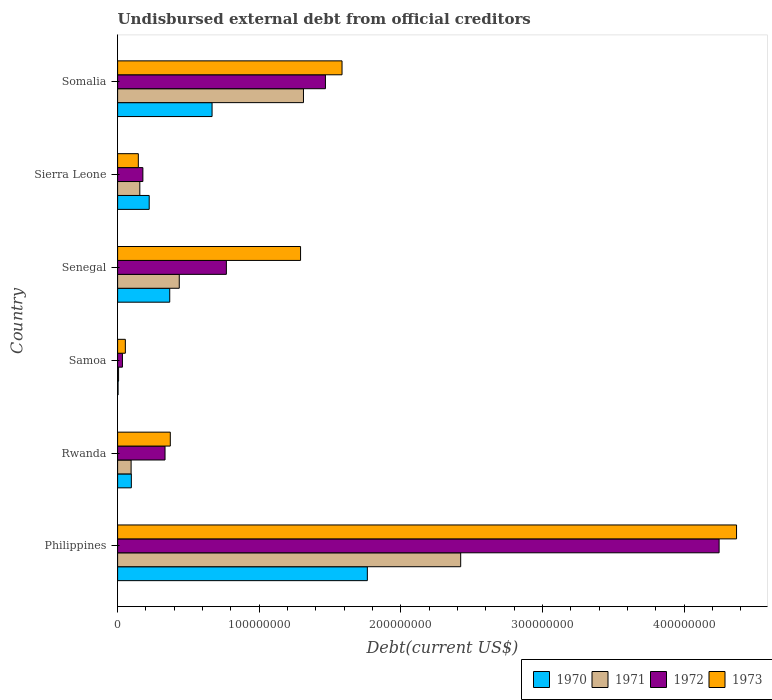Are the number of bars on each tick of the Y-axis equal?
Keep it short and to the point. Yes. What is the label of the 3rd group of bars from the top?
Offer a very short reply. Senegal. In how many cases, is the number of bars for a given country not equal to the number of legend labels?
Your answer should be compact. 0. What is the total debt in 1970 in Sierra Leone?
Offer a terse response. 2.23e+07. Across all countries, what is the maximum total debt in 1973?
Make the answer very short. 4.37e+08. Across all countries, what is the minimum total debt in 1971?
Make the answer very short. 6.88e+05. In which country was the total debt in 1971 minimum?
Offer a terse response. Samoa. What is the total total debt in 1972 in the graph?
Your answer should be compact. 7.03e+08. What is the difference between the total debt in 1971 in Sierra Leone and that in Somalia?
Your answer should be very brief. -1.16e+08. What is the difference between the total debt in 1970 in Rwanda and the total debt in 1971 in Senegal?
Make the answer very short. -3.38e+07. What is the average total debt in 1972 per country?
Your response must be concise. 1.17e+08. What is the difference between the total debt in 1970 and total debt in 1971 in Sierra Leone?
Provide a short and direct response. 6.63e+06. In how many countries, is the total debt in 1972 greater than 260000000 US$?
Your answer should be compact. 1. What is the ratio of the total debt in 1972 in Philippines to that in Sierra Leone?
Give a very brief answer. 23.8. What is the difference between the highest and the second highest total debt in 1970?
Give a very brief answer. 1.10e+08. What is the difference between the highest and the lowest total debt in 1973?
Keep it short and to the point. 4.32e+08. Is the sum of the total debt in 1970 in Sierra Leone and Somalia greater than the maximum total debt in 1973 across all countries?
Provide a succinct answer. No. Is it the case that in every country, the sum of the total debt in 1973 and total debt in 1970 is greater than the total debt in 1971?
Make the answer very short. Yes. What is the difference between two consecutive major ticks on the X-axis?
Your answer should be compact. 1.00e+08. Does the graph contain grids?
Your answer should be very brief. No. How are the legend labels stacked?
Offer a very short reply. Horizontal. What is the title of the graph?
Your response must be concise. Undisbursed external debt from official creditors. Does "1982" appear as one of the legend labels in the graph?
Give a very brief answer. No. What is the label or title of the X-axis?
Your response must be concise. Debt(current US$). What is the Debt(current US$) in 1970 in Philippines?
Provide a succinct answer. 1.76e+08. What is the Debt(current US$) of 1971 in Philippines?
Provide a succinct answer. 2.42e+08. What is the Debt(current US$) in 1972 in Philippines?
Your answer should be compact. 4.25e+08. What is the Debt(current US$) in 1973 in Philippines?
Keep it short and to the point. 4.37e+08. What is the Debt(current US$) in 1970 in Rwanda?
Ensure brevity in your answer.  9.70e+06. What is the Debt(current US$) in 1971 in Rwanda?
Ensure brevity in your answer.  9.53e+06. What is the Debt(current US$) in 1972 in Rwanda?
Make the answer very short. 3.35e+07. What is the Debt(current US$) of 1973 in Rwanda?
Your answer should be compact. 3.72e+07. What is the Debt(current US$) in 1970 in Samoa?
Offer a terse response. 3.36e+05. What is the Debt(current US$) of 1971 in Samoa?
Ensure brevity in your answer.  6.88e+05. What is the Debt(current US$) in 1972 in Samoa?
Offer a very short reply. 3.40e+06. What is the Debt(current US$) of 1973 in Samoa?
Make the answer very short. 5.46e+06. What is the Debt(current US$) of 1970 in Senegal?
Provide a succinct answer. 3.68e+07. What is the Debt(current US$) of 1971 in Senegal?
Your answer should be very brief. 4.35e+07. What is the Debt(current US$) of 1972 in Senegal?
Offer a very short reply. 7.68e+07. What is the Debt(current US$) in 1973 in Senegal?
Ensure brevity in your answer.  1.29e+08. What is the Debt(current US$) in 1970 in Sierra Leone?
Your answer should be very brief. 2.23e+07. What is the Debt(current US$) of 1971 in Sierra Leone?
Provide a succinct answer. 1.57e+07. What is the Debt(current US$) in 1972 in Sierra Leone?
Ensure brevity in your answer.  1.78e+07. What is the Debt(current US$) in 1973 in Sierra Leone?
Provide a short and direct response. 1.46e+07. What is the Debt(current US$) of 1970 in Somalia?
Provide a short and direct response. 6.67e+07. What is the Debt(current US$) of 1971 in Somalia?
Make the answer very short. 1.31e+08. What is the Debt(current US$) of 1972 in Somalia?
Make the answer very short. 1.47e+08. What is the Debt(current US$) of 1973 in Somalia?
Your response must be concise. 1.58e+08. Across all countries, what is the maximum Debt(current US$) of 1970?
Give a very brief answer. 1.76e+08. Across all countries, what is the maximum Debt(current US$) of 1971?
Your answer should be compact. 2.42e+08. Across all countries, what is the maximum Debt(current US$) of 1972?
Your answer should be compact. 4.25e+08. Across all countries, what is the maximum Debt(current US$) of 1973?
Ensure brevity in your answer.  4.37e+08. Across all countries, what is the minimum Debt(current US$) in 1970?
Your answer should be very brief. 3.36e+05. Across all countries, what is the minimum Debt(current US$) in 1971?
Keep it short and to the point. 6.88e+05. Across all countries, what is the minimum Debt(current US$) in 1972?
Offer a terse response. 3.40e+06. Across all countries, what is the minimum Debt(current US$) in 1973?
Give a very brief answer. 5.46e+06. What is the total Debt(current US$) in 1970 in the graph?
Keep it short and to the point. 3.12e+08. What is the total Debt(current US$) in 1971 in the graph?
Provide a succinct answer. 4.43e+08. What is the total Debt(current US$) of 1972 in the graph?
Your answer should be compact. 7.03e+08. What is the total Debt(current US$) of 1973 in the graph?
Your response must be concise. 7.82e+08. What is the difference between the Debt(current US$) of 1970 in Philippines and that in Rwanda?
Provide a succinct answer. 1.67e+08. What is the difference between the Debt(current US$) of 1971 in Philippines and that in Rwanda?
Provide a succinct answer. 2.33e+08. What is the difference between the Debt(current US$) in 1972 in Philippines and that in Rwanda?
Make the answer very short. 3.91e+08. What is the difference between the Debt(current US$) of 1973 in Philippines and that in Rwanda?
Provide a succinct answer. 4.00e+08. What is the difference between the Debt(current US$) in 1970 in Philippines and that in Samoa?
Keep it short and to the point. 1.76e+08. What is the difference between the Debt(current US$) of 1971 in Philippines and that in Samoa?
Make the answer very short. 2.42e+08. What is the difference between the Debt(current US$) of 1972 in Philippines and that in Samoa?
Your response must be concise. 4.21e+08. What is the difference between the Debt(current US$) of 1973 in Philippines and that in Samoa?
Offer a terse response. 4.32e+08. What is the difference between the Debt(current US$) of 1970 in Philippines and that in Senegal?
Make the answer very short. 1.40e+08. What is the difference between the Debt(current US$) in 1971 in Philippines and that in Senegal?
Make the answer very short. 1.99e+08. What is the difference between the Debt(current US$) of 1972 in Philippines and that in Senegal?
Offer a terse response. 3.48e+08. What is the difference between the Debt(current US$) in 1973 in Philippines and that in Senegal?
Provide a short and direct response. 3.08e+08. What is the difference between the Debt(current US$) of 1970 in Philippines and that in Sierra Leone?
Ensure brevity in your answer.  1.54e+08. What is the difference between the Debt(current US$) of 1971 in Philippines and that in Sierra Leone?
Keep it short and to the point. 2.27e+08. What is the difference between the Debt(current US$) in 1972 in Philippines and that in Sierra Leone?
Keep it short and to the point. 4.07e+08. What is the difference between the Debt(current US$) of 1973 in Philippines and that in Sierra Leone?
Your answer should be compact. 4.22e+08. What is the difference between the Debt(current US$) of 1970 in Philippines and that in Somalia?
Give a very brief answer. 1.10e+08. What is the difference between the Debt(current US$) in 1971 in Philippines and that in Somalia?
Ensure brevity in your answer.  1.11e+08. What is the difference between the Debt(current US$) in 1972 in Philippines and that in Somalia?
Offer a very short reply. 2.78e+08. What is the difference between the Debt(current US$) in 1973 in Philippines and that in Somalia?
Your answer should be very brief. 2.79e+08. What is the difference between the Debt(current US$) in 1970 in Rwanda and that in Samoa?
Your answer should be compact. 9.36e+06. What is the difference between the Debt(current US$) of 1971 in Rwanda and that in Samoa?
Your answer should be very brief. 8.84e+06. What is the difference between the Debt(current US$) in 1972 in Rwanda and that in Samoa?
Provide a succinct answer. 3.01e+07. What is the difference between the Debt(current US$) of 1973 in Rwanda and that in Samoa?
Your answer should be compact. 3.17e+07. What is the difference between the Debt(current US$) in 1970 in Rwanda and that in Senegal?
Provide a short and direct response. -2.71e+07. What is the difference between the Debt(current US$) of 1971 in Rwanda and that in Senegal?
Make the answer very short. -3.40e+07. What is the difference between the Debt(current US$) of 1972 in Rwanda and that in Senegal?
Ensure brevity in your answer.  -4.33e+07. What is the difference between the Debt(current US$) in 1973 in Rwanda and that in Senegal?
Your answer should be very brief. -9.20e+07. What is the difference between the Debt(current US$) in 1970 in Rwanda and that in Sierra Leone?
Your answer should be compact. -1.26e+07. What is the difference between the Debt(current US$) in 1971 in Rwanda and that in Sierra Leone?
Your answer should be compact. -6.14e+06. What is the difference between the Debt(current US$) in 1972 in Rwanda and that in Sierra Leone?
Keep it short and to the point. 1.56e+07. What is the difference between the Debt(current US$) of 1973 in Rwanda and that in Sierra Leone?
Make the answer very short. 2.26e+07. What is the difference between the Debt(current US$) in 1970 in Rwanda and that in Somalia?
Your response must be concise. -5.70e+07. What is the difference between the Debt(current US$) in 1971 in Rwanda and that in Somalia?
Ensure brevity in your answer.  -1.22e+08. What is the difference between the Debt(current US$) of 1972 in Rwanda and that in Somalia?
Provide a succinct answer. -1.13e+08. What is the difference between the Debt(current US$) in 1973 in Rwanda and that in Somalia?
Your answer should be very brief. -1.21e+08. What is the difference between the Debt(current US$) in 1970 in Samoa and that in Senegal?
Your answer should be very brief. -3.65e+07. What is the difference between the Debt(current US$) of 1971 in Samoa and that in Senegal?
Your answer should be very brief. -4.29e+07. What is the difference between the Debt(current US$) of 1972 in Samoa and that in Senegal?
Give a very brief answer. -7.34e+07. What is the difference between the Debt(current US$) of 1973 in Samoa and that in Senegal?
Keep it short and to the point. -1.24e+08. What is the difference between the Debt(current US$) in 1970 in Samoa and that in Sierra Leone?
Offer a terse response. -2.20e+07. What is the difference between the Debt(current US$) of 1971 in Samoa and that in Sierra Leone?
Provide a succinct answer. -1.50e+07. What is the difference between the Debt(current US$) in 1972 in Samoa and that in Sierra Leone?
Give a very brief answer. -1.44e+07. What is the difference between the Debt(current US$) of 1973 in Samoa and that in Sierra Leone?
Your answer should be compact. -9.17e+06. What is the difference between the Debt(current US$) of 1970 in Samoa and that in Somalia?
Your response must be concise. -6.64e+07. What is the difference between the Debt(current US$) in 1971 in Samoa and that in Somalia?
Make the answer very short. -1.31e+08. What is the difference between the Debt(current US$) of 1972 in Samoa and that in Somalia?
Offer a terse response. -1.43e+08. What is the difference between the Debt(current US$) of 1973 in Samoa and that in Somalia?
Provide a succinct answer. -1.53e+08. What is the difference between the Debt(current US$) in 1970 in Senegal and that in Sierra Leone?
Ensure brevity in your answer.  1.45e+07. What is the difference between the Debt(current US$) in 1971 in Senegal and that in Sierra Leone?
Provide a short and direct response. 2.79e+07. What is the difference between the Debt(current US$) in 1972 in Senegal and that in Sierra Leone?
Offer a very short reply. 5.90e+07. What is the difference between the Debt(current US$) in 1973 in Senegal and that in Sierra Leone?
Provide a short and direct response. 1.15e+08. What is the difference between the Debt(current US$) of 1970 in Senegal and that in Somalia?
Provide a succinct answer. -2.99e+07. What is the difference between the Debt(current US$) of 1971 in Senegal and that in Somalia?
Make the answer very short. -8.77e+07. What is the difference between the Debt(current US$) of 1972 in Senegal and that in Somalia?
Your answer should be compact. -7.00e+07. What is the difference between the Debt(current US$) in 1973 in Senegal and that in Somalia?
Provide a short and direct response. -2.93e+07. What is the difference between the Debt(current US$) in 1970 in Sierra Leone and that in Somalia?
Ensure brevity in your answer.  -4.44e+07. What is the difference between the Debt(current US$) of 1971 in Sierra Leone and that in Somalia?
Provide a short and direct response. -1.16e+08. What is the difference between the Debt(current US$) in 1972 in Sierra Leone and that in Somalia?
Provide a succinct answer. -1.29e+08. What is the difference between the Debt(current US$) of 1973 in Sierra Leone and that in Somalia?
Offer a very short reply. -1.44e+08. What is the difference between the Debt(current US$) in 1970 in Philippines and the Debt(current US$) in 1971 in Rwanda?
Your answer should be very brief. 1.67e+08. What is the difference between the Debt(current US$) in 1970 in Philippines and the Debt(current US$) in 1972 in Rwanda?
Give a very brief answer. 1.43e+08. What is the difference between the Debt(current US$) in 1970 in Philippines and the Debt(current US$) in 1973 in Rwanda?
Provide a succinct answer. 1.39e+08. What is the difference between the Debt(current US$) of 1971 in Philippines and the Debt(current US$) of 1972 in Rwanda?
Your answer should be compact. 2.09e+08. What is the difference between the Debt(current US$) of 1971 in Philippines and the Debt(current US$) of 1973 in Rwanda?
Offer a terse response. 2.05e+08. What is the difference between the Debt(current US$) of 1972 in Philippines and the Debt(current US$) of 1973 in Rwanda?
Offer a very short reply. 3.88e+08. What is the difference between the Debt(current US$) of 1970 in Philippines and the Debt(current US$) of 1971 in Samoa?
Keep it short and to the point. 1.76e+08. What is the difference between the Debt(current US$) in 1970 in Philippines and the Debt(current US$) in 1972 in Samoa?
Make the answer very short. 1.73e+08. What is the difference between the Debt(current US$) in 1970 in Philippines and the Debt(current US$) in 1973 in Samoa?
Your answer should be very brief. 1.71e+08. What is the difference between the Debt(current US$) in 1971 in Philippines and the Debt(current US$) in 1972 in Samoa?
Provide a short and direct response. 2.39e+08. What is the difference between the Debt(current US$) of 1971 in Philippines and the Debt(current US$) of 1973 in Samoa?
Give a very brief answer. 2.37e+08. What is the difference between the Debt(current US$) of 1972 in Philippines and the Debt(current US$) of 1973 in Samoa?
Your answer should be very brief. 4.19e+08. What is the difference between the Debt(current US$) in 1970 in Philippines and the Debt(current US$) in 1971 in Senegal?
Offer a very short reply. 1.33e+08. What is the difference between the Debt(current US$) of 1970 in Philippines and the Debt(current US$) of 1972 in Senegal?
Provide a short and direct response. 9.96e+07. What is the difference between the Debt(current US$) in 1970 in Philippines and the Debt(current US$) in 1973 in Senegal?
Your answer should be compact. 4.72e+07. What is the difference between the Debt(current US$) in 1971 in Philippines and the Debt(current US$) in 1972 in Senegal?
Your answer should be very brief. 1.65e+08. What is the difference between the Debt(current US$) in 1971 in Philippines and the Debt(current US$) in 1973 in Senegal?
Offer a very short reply. 1.13e+08. What is the difference between the Debt(current US$) in 1972 in Philippines and the Debt(current US$) in 1973 in Senegal?
Your answer should be compact. 2.96e+08. What is the difference between the Debt(current US$) in 1970 in Philippines and the Debt(current US$) in 1971 in Sierra Leone?
Offer a terse response. 1.61e+08. What is the difference between the Debt(current US$) in 1970 in Philippines and the Debt(current US$) in 1972 in Sierra Leone?
Make the answer very short. 1.59e+08. What is the difference between the Debt(current US$) of 1970 in Philippines and the Debt(current US$) of 1973 in Sierra Leone?
Ensure brevity in your answer.  1.62e+08. What is the difference between the Debt(current US$) in 1971 in Philippines and the Debt(current US$) in 1972 in Sierra Leone?
Give a very brief answer. 2.24e+08. What is the difference between the Debt(current US$) in 1971 in Philippines and the Debt(current US$) in 1973 in Sierra Leone?
Provide a short and direct response. 2.28e+08. What is the difference between the Debt(current US$) in 1972 in Philippines and the Debt(current US$) in 1973 in Sierra Leone?
Ensure brevity in your answer.  4.10e+08. What is the difference between the Debt(current US$) in 1970 in Philippines and the Debt(current US$) in 1971 in Somalia?
Your response must be concise. 4.51e+07. What is the difference between the Debt(current US$) in 1970 in Philippines and the Debt(current US$) in 1972 in Somalia?
Your answer should be compact. 2.96e+07. What is the difference between the Debt(current US$) of 1970 in Philippines and the Debt(current US$) of 1973 in Somalia?
Provide a succinct answer. 1.79e+07. What is the difference between the Debt(current US$) in 1971 in Philippines and the Debt(current US$) in 1972 in Somalia?
Your answer should be compact. 9.55e+07. What is the difference between the Debt(current US$) in 1971 in Philippines and the Debt(current US$) in 1973 in Somalia?
Offer a terse response. 8.38e+07. What is the difference between the Debt(current US$) of 1972 in Philippines and the Debt(current US$) of 1973 in Somalia?
Your answer should be very brief. 2.66e+08. What is the difference between the Debt(current US$) of 1970 in Rwanda and the Debt(current US$) of 1971 in Samoa?
Provide a succinct answer. 9.01e+06. What is the difference between the Debt(current US$) in 1970 in Rwanda and the Debt(current US$) in 1972 in Samoa?
Provide a short and direct response. 6.29e+06. What is the difference between the Debt(current US$) in 1970 in Rwanda and the Debt(current US$) in 1973 in Samoa?
Your answer should be very brief. 4.23e+06. What is the difference between the Debt(current US$) of 1971 in Rwanda and the Debt(current US$) of 1972 in Samoa?
Keep it short and to the point. 6.13e+06. What is the difference between the Debt(current US$) in 1971 in Rwanda and the Debt(current US$) in 1973 in Samoa?
Offer a terse response. 4.07e+06. What is the difference between the Debt(current US$) in 1972 in Rwanda and the Debt(current US$) in 1973 in Samoa?
Make the answer very short. 2.80e+07. What is the difference between the Debt(current US$) of 1970 in Rwanda and the Debt(current US$) of 1971 in Senegal?
Provide a short and direct response. -3.38e+07. What is the difference between the Debt(current US$) in 1970 in Rwanda and the Debt(current US$) in 1972 in Senegal?
Ensure brevity in your answer.  -6.71e+07. What is the difference between the Debt(current US$) in 1970 in Rwanda and the Debt(current US$) in 1973 in Senegal?
Provide a short and direct response. -1.20e+08. What is the difference between the Debt(current US$) of 1971 in Rwanda and the Debt(current US$) of 1972 in Senegal?
Keep it short and to the point. -6.73e+07. What is the difference between the Debt(current US$) in 1971 in Rwanda and the Debt(current US$) in 1973 in Senegal?
Provide a succinct answer. -1.20e+08. What is the difference between the Debt(current US$) of 1972 in Rwanda and the Debt(current US$) of 1973 in Senegal?
Give a very brief answer. -9.57e+07. What is the difference between the Debt(current US$) in 1970 in Rwanda and the Debt(current US$) in 1971 in Sierra Leone?
Give a very brief answer. -5.98e+06. What is the difference between the Debt(current US$) of 1970 in Rwanda and the Debt(current US$) of 1972 in Sierra Leone?
Keep it short and to the point. -8.15e+06. What is the difference between the Debt(current US$) in 1970 in Rwanda and the Debt(current US$) in 1973 in Sierra Leone?
Your answer should be compact. -4.93e+06. What is the difference between the Debt(current US$) in 1971 in Rwanda and the Debt(current US$) in 1972 in Sierra Leone?
Provide a short and direct response. -8.32e+06. What is the difference between the Debt(current US$) of 1971 in Rwanda and the Debt(current US$) of 1973 in Sierra Leone?
Make the answer very short. -5.10e+06. What is the difference between the Debt(current US$) of 1972 in Rwanda and the Debt(current US$) of 1973 in Sierra Leone?
Your answer should be very brief. 1.89e+07. What is the difference between the Debt(current US$) in 1970 in Rwanda and the Debt(current US$) in 1971 in Somalia?
Offer a very short reply. -1.22e+08. What is the difference between the Debt(current US$) of 1970 in Rwanda and the Debt(current US$) of 1972 in Somalia?
Your answer should be compact. -1.37e+08. What is the difference between the Debt(current US$) in 1970 in Rwanda and the Debt(current US$) in 1973 in Somalia?
Keep it short and to the point. -1.49e+08. What is the difference between the Debt(current US$) of 1971 in Rwanda and the Debt(current US$) of 1972 in Somalia?
Offer a very short reply. -1.37e+08. What is the difference between the Debt(current US$) of 1971 in Rwanda and the Debt(current US$) of 1973 in Somalia?
Make the answer very short. -1.49e+08. What is the difference between the Debt(current US$) of 1972 in Rwanda and the Debt(current US$) of 1973 in Somalia?
Ensure brevity in your answer.  -1.25e+08. What is the difference between the Debt(current US$) of 1970 in Samoa and the Debt(current US$) of 1971 in Senegal?
Your response must be concise. -4.32e+07. What is the difference between the Debt(current US$) of 1970 in Samoa and the Debt(current US$) of 1972 in Senegal?
Make the answer very short. -7.65e+07. What is the difference between the Debt(current US$) of 1970 in Samoa and the Debt(current US$) of 1973 in Senegal?
Provide a short and direct response. -1.29e+08. What is the difference between the Debt(current US$) of 1971 in Samoa and the Debt(current US$) of 1972 in Senegal?
Your answer should be compact. -7.61e+07. What is the difference between the Debt(current US$) in 1971 in Samoa and the Debt(current US$) in 1973 in Senegal?
Your answer should be very brief. -1.29e+08. What is the difference between the Debt(current US$) of 1972 in Samoa and the Debt(current US$) of 1973 in Senegal?
Give a very brief answer. -1.26e+08. What is the difference between the Debt(current US$) in 1970 in Samoa and the Debt(current US$) in 1971 in Sierra Leone?
Keep it short and to the point. -1.53e+07. What is the difference between the Debt(current US$) of 1970 in Samoa and the Debt(current US$) of 1972 in Sierra Leone?
Keep it short and to the point. -1.75e+07. What is the difference between the Debt(current US$) of 1970 in Samoa and the Debt(current US$) of 1973 in Sierra Leone?
Ensure brevity in your answer.  -1.43e+07. What is the difference between the Debt(current US$) of 1971 in Samoa and the Debt(current US$) of 1972 in Sierra Leone?
Keep it short and to the point. -1.72e+07. What is the difference between the Debt(current US$) of 1971 in Samoa and the Debt(current US$) of 1973 in Sierra Leone?
Provide a short and direct response. -1.39e+07. What is the difference between the Debt(current US$) in 1972 in Samoa and the Debt(current US$) in 1973 in Sierra Leone?
Provide a short and direct response. -1.12e+07. What is the difference between the Debt(current US$) in 1970 in Samoa and the Debt(current US$) in 1971 in Somalia?
Ensure brevity in your answer.  -1.31e+08. What is the difference between the Debt(current US$) in 1970 in Samoa and the Debt(current US$) in 1972 in Somalia?
Give a very brief answer. -1.46e+08. What is the difference between the Debt(current US$) of 1970 in Samoa and the Debt(current US$) of 1973 in Somalia?
Your response must be concise. -1.58e+08. What is the difference between the Debt(current US$) of 1971 in Samoa and the Debt(current US$) of 1972 in Somalia?
Make the answer very short. -1.46e+08. What is the difference between the Debt(current US$) of 1971 in Samoa and the Debt(current US$) of 1973 in Somalia?
Your response must be concise. -1.58e+08. What is the difference between the Debt(current US$) of 1972 in Samoa and the Debt(current US$) of 1973 in Somalia?
Make the answer very short. -1.55e+08. What is the difference between the Debt(current US$) in 1970 in Senegal and the Debt(current US$) in 1971 in Sierra Leone?
Your response must be concise. 2.11e+07. What is the difference between the Debt(current US$) of 1970 in Senegal and the Debt(current US$) of 1972 in Sierra Leone?
Your response must be concise. 1.90e+07. What is the difference between the Debt(current US$) in 1970 in Senegal and the Debt(current US$) in 1973 in Sierra Leone?
Give a very brief answer. 2.22e+07. What is the difference between the Debt(current US$) of 1971 in Senegal and the Debt(current US$) of 1972 in Sierra Leone?
Provide a succinct answer. 2.57e+07. What is the difference between the Debt(current US$) in 1971 in Senegal and the Debt(current US$) in 1973 in Sierra Leone?
Your answer should be compact. 2.89e+07. What is the difference between the Debt(current US$) of 1972 in Senegal and the Debt(current US$) of 1973 in Sierra Leone?
Your answer should be compact. 6.22e+07. What is the difference between the Debt(current US$) in 1970 in Senegal and the Debt(current US$) in 1971 in Somalia?
Give a very brief answer. -9.44e+07. What is the difference between the Debt(current US$) in 1970 in Senegal and the Debt(current US$) in 1972 in Somalia?
Offer a terse response. -1.10e+08. What is the difference between the Debt(current US$) of 1970 in Senegal and the Debt(current US$) of 1973 in Somalia?
Your response must be concise. -1.22e+08. What is the difference between the Debt(current US$) of 1971 in Senegal and the Debt(current US$) of 1972 in Somalia?
Provide a succinct answer. -1.03e+08. What is the difference between the Debt(current US$) of 1971 in Senegal and the Debt(current US$) of 1973 in Somalia?
Offer a terse response. -1.15e+08. What is the difference between the Debt(current US$) in 1972 in Senegal and the Debt(current US$) in 1973 in Somalia?
Offer a very short reply. -8.17e+07. What is the difference between the Debt(current US$) of 1970 in Sierra Leone and the Debt(current US$) of 1971 in Somalia?
Your response must be concise. -1.09e+08. What is the difference between the Debt(current US$) of 1970 in Sierra Leone and the Debt(current US$) of 1972 in Somalia?
Provide a succinct answer. -1.24e+08. What is the difference between the Debt(current US$) in 1970 in Sierra Leone and the Debt(current US$) in 1973 in Somalia?
Offer a very short reply. -1.36e+08. What is the difference between the Debt(current US$) in 1971 in Sierra Leone and the Debt(current US$) in 1972 in Somalia?
Provide a succinct answer. -1.31e+08. What is the difference between the Debt(current US$) in 1971 in Sierra Leone and the Debt(current US$) in 1973 in Somalia?
Provide a short and direct response. -1.43e+08. What is the difference between the Debt(current US$) of 1972 in Sierra Leone and the Debt(current US$) of 1973 in Somalia?
Your answer should be compact. -1.41e+08. What is the average Debt(current US$) in 1970 per country?
Your answer should be compact. 5.20e+07. What is the average Debt(current US$) in 1971 per country?
Give a very brief answer. 7.38e+07. What is the average Debt(current US$) of 1972 per country?
Provide a short and direct response. 1.17e+08. What is the average Debt(current US$) in 1973 per country?
Provide a short and direct response. 1.30e+08. What is the difference between the Debt(current US$) in 1970 and Debt(current US$) in 1971 in Philippines?
Provide a short and direct response. -6.59e+07. What is the difference between the Debt(current US$) of 1970 and Debt(current US$) of 1972 in Philippines?
Your response must be concise. -2.48e+08. What is the difference between the Debt(current US$) in 1970 and Debt(current US$) in 1973 in Philippines?
Your answer should be compact. -2.61e+08. What is the difference between the Debt(current US$) in 1971 and Debt(current US$) in 1972 in Philippines?
Offer a terse response. -1.83e+08. What is the difference between the Debt(current US$) of 1971 and Debt(current US$) of 1973 in Philippines?
Your answer should be compact. -1.95e+08. What is the difference between the Debt(current US$) of 1972 and Debt(current US$) of 1973 in Philippines?
Provide a short and direct response. -1.23e+07. What is the difference between the Debt(current US$) in 1970 and Debt(current US$) in 1971 in Rwanda?
Offer a terse response. 1.63e+05. What is the difference between the Debt(current US$) of 1970 and Debt(current US$) of 1972 in Rwanda?
Your response must be concise. -2.38e+07. What is the difference between the Debt(current US$) of 1970 and Debt(current US$) of 1973 in Rwanda?
Your response must be concise. -2.75e+07. What is the difference between the Debt(current US$) in 1971 and Debt(current US$) in 1972 in Rwanda?
Make the answer very short. -2.40e+07. What is the difference between the Debt(current US$) in 1971 and Debt(current US$) in 1973 in Rwanda?
Your answer should be very brief. -2.77e+07. What is the difference between the Debt(current US$) in 1972 and Debt(current US$) in 1973 in Rwanda?
Offer a terse response. -3.72e+06. What is the difference between the Debt(current US$) in 1970 and Debt(current US$) in 1971 in Samoa?
Keep it short and to the point. -3.52e+05. What is the difference between the Debt(current US$) in 1970 and Debt(current US$) in 1972 in Samoa?
Offer a very short reply. -3.07e+06. What is the difference between the Debt(current US$) of 1970 and Debt(current US$) of 1973 in Samoa?
Keep it short and to the point. -5.13e+06. What is the difference between the Debt(current US$) in 1971 and Debt(current US$) in 1972 in Samoa?
Offer a very short reply. -2.72e+06. What is the difference between the Debt(current US$) in 1971 and Debt(current US$) in 1973 in Samoa?
Provide a short and direct response. -4.77e+06. What is the difference between the Debt(current US$) in 1972 and Debt(current US$) in 1973 in Samoa?
Your answer should be very brief. -2.06e+06. What is the difference between the Debt(current US$) of 1970 and Debt(current US$) of 1971 in Senegal?
Your answer should be very brief. -6.72e+06. What is the difference between the Debt(current US$) in 1970 and Debt(current US$) in 1972 in Senegal?
Keep it short and to the point. -4.00e+07. What is the difference between the Debt(current US$) of 1970 and Debt(current US$) of 1973 in Senegal?
Provide a succinct answer. -9.24e+07. What is the difference between the Debt(current US$) of 1971 and Debt(current US$) of 1972 in Senegal?
Your answer should be very brief. -3.33e+07. What is the difference between the Debt(current US$) in 1971 and Debt(current US$) in 1973 in Senegal?
Provide a succinct answer. -8.57e+07. What is the difference between the Debt(current US$) in 1972 and Debt(current US$) in 1973 in Senegal?
Keep it short and to the point. -5.24e+07. What is the difference between the Debt(current US$) in 1970 and Debt(current US$) in 1971 in Sierra Leone?
Give a very brief answer. 6.63e+06. What is the difference between the Debt(current US$) of 1970 and Debt(current US$) of 1972 in Sierra Leone?
Keep it short and to the point. 4.46e+06. What is the difference between the Debt(current US$) in 1970 and Debt(current US$) in 1973 in Sierra Leone?
Offer a terse response. 7.68e+06. What is the difference between the Debt(current US$) of 1971 and Debt(current US$) of 1972 in Sierra Leone?
Your response must be concise. -2.17e+06. What is the difference between the Debt(current US$) of 1971 and Debt(current US$) of 1973 in Sierra Leone?
Your response must be concise. 1.05e+06. What is the difference between the Debt(current US$) in 1972 and Debt(current US$) in 1973 in Sierra Leone?
Provide a succinct answer. 3.22e+06. What is the difference between the Debt(current US$) in 1970 and Debt(current US$) in 1971 in Somalia?
Provide a succinct answer. -6.45e+07. What is the difference between the Debt(current US$) in 1970 and Debt(current US$) in 1972 in Somalia?
Ensure brevity in your answer.  -8.01e+07. What is the difference between the Debt(current US$) in 1970 and Debt(current US$) in 1973 in Somalia?
Offer a very short reply. -9.18e+07. What is the difference between the Debt(current US$) of 1971 and Debt(current US$) of 1972 in Somalia?
Ensure brevity in your answer.  -1.55e+07. What is the difference between the Debt(current US$) of 1971 and Debt(current US$) of 1973 in Somalia?
Your answer should be compact. -2.72e+07. What is the difference between the Debt(current US$) in 1972 and Debt(current US$) in 1973 in Somalia?
Your response must be concise. -1.17e+07. What is the ratio of the Debt(current US$) in 1970 in Philippines to that in Rwanda?
Give a very brief answer. 18.19. What is the ratio of the Debt(current US$) in 1971 in Philippines to that in Rwanda?
Your answer should be compact. 25.42. What is the ratio of the Debt(current US$) of 1972 in Philippines to that in Rwanda?
Your answer should be compact. 12.68. What is the ratio of the Debt(current US$) of 1973 in Philippines to that in Rwanda?
Offer a very short reply. 11.75. What is the ratio of the Debt(current US$) of 1970 in Philippines to that in Samoa?
Give a very brief answer. 524.93. What is the ratio of the Debt(current US$) in 1971 in Philippines to that in Samoa?
Offer a very short reply. 352.16. What is the ratio of the Debt(current US$) in 1972 in Philippines to that in Samoa?
Keep it short and to the point. 124.76. What is the ratio of the Debt(current US$) in 1973 in Philippines to that in Samoa?
Offer a very short reply. 80.03. What is the ratio of the Debt(current US$) of 1970 in Philippines to that in Senegal?
Offer a very short reply. 4.79. What is the ratio of the Debt(current US$) of 1971 in Philippines to that in Senegal?
Make the answer very short. 5.56. What is the ratio of the Debt(current US$) in 1972 in Philippines to that in Senegal?
Your answer should be very brief. 5.53. What is the ratio of the Debt(current US$) of 1973 in Philippines to that in Senegal?
Provide a succinct answer. 3.38. What is the ratio of the Debt(current US$) in 1970 in Philippines to that in Sierra Leone?
Make the answer very short. 7.91. What is the ratio of the Debt(current US$) in 1971 in Philippines to that in Sierra Leone?
Offer a terse response. 15.46. What is the ratio of the Debt(current US$) in 1972 in Philippines to that in Sierra Leone?
Ensure brevity in your answer.  23.8. What is the ratio of the Debt(current US$) of 1973 in Philippines to that in Sierra Leone?
Your answer should be very brief. 29.88. What is the ratio of the Debt(current US$) of 1970 in Philippines to that in Somalia?
Your answer should be very brief. 2.64. What is the ratio of the Debt(current US$) of 1971 in Philippines to that in Somalia?
Give a very brief answer. 1.85. What is the ratio of the Debt(current US$) in 1972 in Philippines to that in Somalia?
Make the answer very short. 2.89. What is the ratio of the Debt(current US$) of 1973 in Philippines to that in Somalia?
Your answer should be very brief. 2.76. What is the ratio of the Debt(current US$) in 1970 in Rwanda to that in Samoa?
Keep it short and to the point. 28.86. What is the ratio of the Debt(current US$) in 1971 in Rwanda to that in Samoa?
Your answer should be compact. 13.86. What is the ratio of the Debt(current US$) of 1972 in Rwanda to that in Samoa?
Ensure brevity in your answer.  9.84. What is the ratio of the Debt(current US$) in 1973 in Rwanda to that in Samoa?
Give a very brief answer. 6.81. What is the ratio of the Debt(current US$) in 1970 in Rwanda to that in Senegal?
Your answer should be compact. 0.26. What is the ratio of the Debt(current US$) in 1971 in Rwanda to that in Senegal?
Keep it short and to the point. 0.22. What is the ratio of the Debt(current US$) of 1972 in Rwanda to that in Senegal?
Offer a terse response. 0.44. What is the ratio of the Debt(current US$) of 1973 in Rwanda to that in Senegal?
Offer a terse response. 0.29. What is the ratio of the Debt(current US$) of 1970 in Rwanda to that in Sierra Leone?
Make the answer very short. 0.43. What is the ratio of the Debt(current US$) in 1971 in Rwanda to that in Sierra Leone?
Keep it short and to the point. 0.61. What is the ratio of the Debt(current US$) of 1972 in Rwanda to that in Sierra Leone?
Ensure brevity in your answer.  1.88. What is the ratio of the Debt(current US$) in 1973 in Rwanda to that in Sierra Leone?
Provide a short and direct response. 2.54. What is the ratio of the Debt(current US$) of 1970 in Rwanda to that in Somalia?
Your answer should be very brief. 0.15. What is the ratio of the Debt(current US$) of 1971 in Rwanda to that in Somalia?
Your response must be concise. 0.07. What is the ratio of the Debt(current US$) in 1972 in Rwanda to that in Somalia?
Make the answer very short. 0.23. What is the ratio of the Debt(current US$) of 1973 in Rwanda to that in Somalia?
Offer a very short reply. 0.23. What is the ratio of the Debt(current US$) in 1970 in Samoa to that in Senegal?
Make the answer very short. 0.01. What is the ratio of the Debt(current US$) in 1971 in Samoa to that in Senegal?
Your answer should be very brief. 0.02. What is the ratio of the Debt(current US$) in 1972 in Samoa to that in Senegal?
Give a very brief answer. 0.04. What is the ratio of the Debt(current US$) of 1973 in Samoa to that in Senegal?
Provide a short and direct response. 0.04. What is the ratio of the Debt(current US$) in 1970 in Samoa to that in Sierra Leone?
Keep it short and to the point. 0.02. What is the ratio of the Debt(current US$) in 1971 in Samoa to that in Sierra Leone?
Make the answer very short. 0.04. What is the ratio of the Debt(current US$) in 1972 in Samoa to that in Sierra Leone?
Your answer should be compact. 0.19. What is the ratio of the Debt(current US$) in 1973 in Samoa to that in Sierra Leone?
Make the answer very short. 0.37. What is the ratio of the Debt(current US$) in 1970 in Samoa to that in Somalia?
Offer a very short reply. 0.01. What is the ratio of the Debt(current US$) of 1971 in Samoa to that in Somalia?
Give a very brief answer. 0.01. What is the ratio of the Debt(current US$) in 1972 in Samoa to that in Somalia?
Your answer should be very brief. 0.02. What is the ratio of the Debt(current US$) of 1973 in Samoa to that in Somalia?
Make the answer very short. 0.03. What is the ratio of the Debt(current US$) in 1970 in Senegal to that in Sierra Leone?
Offer a very short reply. 1.65. What is the ratio of the Debt(current US$) in 1971 in Senegal to that in Sierra Leone?
Your response must be concise. 2.78. What is the ratio of the Debt(current US$) in 1972 in Senegal to that in Sierra Leone?
Provide a succinct answer. 4.3. What is the ratio of the Debt(current US$) of 1973 in Senegal to that in Sierra Leone?
Provide a succinct answer. 8.83. What is the ratio of the Debt(current US$) in 1970 in Senegal to that in Somalia?
Your response must be concise. 0.55. What is the ratio of the Debt(current US$) in 1971 in Senegal to that in Somalia?
Offer a very short reply. 0.33. What is the ratio of the Debt(current US$) of 1972 in Senegal to that in Somalia?
Offer a terse response. 0.52. What is the ratio of the Debt(current US$) in 1973 in Senegal to that in Somalia?
Provide a short and direct response. 0.82. What is the ratio of the Debt(current US$) in 1970 in Sierra Leone to that in Somalia?
Provide a succinct answer. 0.33. What is the ratio of the Debt(current US$) in 1971 in Sierra Leone to that in Somalia?
Provide a succinct answer. 0.12. What is the ratio of the Debt(current US$) of 1972 in Sierra Leone to that in Somalia?
Your answer should be very brief. 0.12. What is the ratio of the Debt(current US$) of 1973 in Sierra Leone to that in Somalia?
Your response must be concise. 0.09. What is the difference between the highest and the second highest Debt(current US$) of 1970?
Provide a short and direct response. 1.10e+08. What is the difference between the highest and the second highest Debt(current US$) of 1971?
Provide a succinct answer. 1.11e+08. What is the difference between the highest and the second highest Debt(current US$) of 1972?
Your response must be concise. 2.78e+08. What is the difference between the highest and the second highest Debt(current US$) in 1973?
Your response must be concise. 2.79e+08. What is the difference between the highest and the lowest Debt(current US$) of 1970?
Your answer should be very brief. 1.76e+08. What is the difference between the highest and the lowest Debt(current US$) of 1971?
Provide a succinct answer. 2.42e+08. What is the difference between the highest and the lowest Debt(current US$) of 1972?
Your answer should be compact. 4.21e+08. What is the difference between the highest and the lowest Debt(current US$) of 1973?
Your answer should be compact. 4.32e+08. 